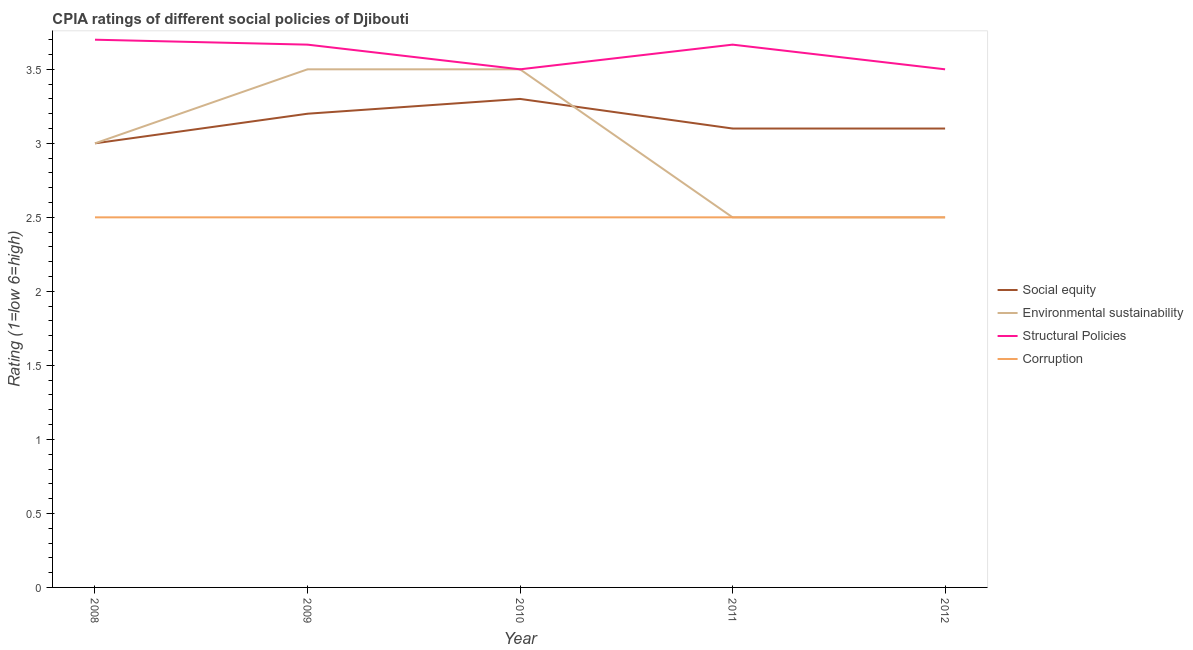Is the number of lines equal to the number of legend labels?
Provide a short and direct response. Yes. Across all years, what is the maximum cpia rating of corruption?
Provide a succinct answer. 2.5. Across all years, what is the minimum cpia rating of corruption?
Ensure brevity in your answer.  2.5. In which year was the cpia rating of corruption minimum?
Your response must be concise. 2008. What is the total cpia rating of environmental sustainability in the graph?
Your answer should be very brief. 15. What is the difference between the cpia rating of environmental sustainability in 2008 and that in 2009?
Ensure brevity in your answer.  -0.5. What is the difference between the cpia rating of social equity in 2010 and the cpia rating of corruption in 2008?
Offer a terse response. 0.8. In the year 2009, what is the difference between the cpia rating of structural policies and cpia rating of corruption?
Ensure brevity in your answer.  1.17. In how many years, is the cpia rating of corruption greater than 1?
Make the answer very short. 5. What is the ratio of the cpia rating of social equity in 2008 to that in 2012?
Your answer should be very brief. 0.97. Is the difference between the cpia rating of structural policies in 2010 and 2011 greater than the difference between the cpia rating of social equity in 2010 and 2011?
Provide a short and direct response. No. What is the difference between the highest and the second highest cpia rating of environmental sustainability?
Provide a short and direct response. 0. What is the difference between the highest and the lowest cpia rating of structural policies?
Offer a terse response. 0.2. Is it the case that in every year, the sum of the cpia rating of social equity and cpia rating of structural policies is greater than the sum of cpia rating of corruption and cpia rating of environmental sustainability?
Your response must be concise. Yes. Is it the case that in every year, the sum of the cpia rating of social equity and cpia rating of environmental sustainability is greater than the cpia rating of structural policies?
Your answer should be very brief. Yes. Does the cpia rating of social equity monotonically increase over the years?
Provide a short and direct response. No. Is the cpia rating of social equity strictly greater than the cpia rating of structural policies over the years?
Give a very brief answer. No. Is the cpia rating of social equity strictly less than the cpia rating of corruption over the years?
Provide a succinct answer. No. How many years are there in the graph?
Your answer should be very brief. 5. What is the difference between two consecutive major ticks on the Y-axis?
Keep it short and to the point. 0.5. Are the values on the major ticks of Y-axis written in scientific E-notation?
Offer a terse response. No. Does the graph contain any zero values?
Your answer should be compact. No. What is the title of the graph?
Your answer should be compact. CPIA ratings of different social policies of Djibouti. What is the label or title of the X-axis?
Your answer should be very brief. Year. What is the Rating (1=low 6=high) in Environmental sustainability in 2008?
Make the answer very short. 3. What is the Rating (1=low 6=high) of Structural Policies in 2009?
Offer a very short reply. 3.67. What is the Rating (1=low 6=high) of Social equity in 2010?
Offer a very short reply. 3.3. What is the Rating (1=low 6=high) of Environmental sustainability in 2010?
Offer a terse response. 3.5. What is the Rating (1=low 6=high) in Corruption in 2010?
Your response must be concise. 2.5. What is the Rating (1=low 6=high) of Environmental sustainability in 2011?
Your response must be concise. 2.5. What is the Rating (1=low 6=high) of Structural Policies in 2011?
Keep it short and to the point. 3.67. What is the Rating (1=low 6=high) in Corruption in 2011?
Make the answer very short. 2.5. What is the Rating (1=low 6=high) in Corruption in 2012?
Offer a very short reply. 2.5. Across all years, what is the minimum Rating (1=low 6=high) in Social equity?
Ensure brevity in your answer.  3. Across all years, what is the minimum Rating (1=low 6=high) in Environmental sustainability?
Your answer should be compact. 2.5. What is the total Rating (1=low 6=high) in Environmental sustainability in the graph?
Give a very brief answer. 15. What is the total Rating (1=low 6=high) of Structural Policies in the graph?
Keep it short and to the point. 18.03. What is the total Rating (1=low 6=high) in Corruption in the graph?
Your answer should be very brief. 12.5. What is the difference between the Rating (1=low 6=high) of Environmental sustainability in 2008 and that in 2009?
Ensure brevity in your answer.  -0.5. What is the difference between the Rating (1=low 6=high) of Structural Policies in 2008 and that in 2009?
Your response must be concise. 0.03. What is the difference between the Rating (1=low 6=high) of Corruption in 2008 and that in 2009?
Offer a terse response. 0. What is the difference between the Rating (1=low 6=high) in Environmental sustainability in 2008 and that in 2010?
Give a very brief answer. -0.5. What is the difference between the Rating (1=low 6=high) in Social equity in 2008 and that in 2011?
Offer a terse response. -0.1. What is the difference between the Rating (1=low 6=high) in Corruption in 2008 and that in 2011?
Your answer should be compact. 0. What is the difference between the Rating (1=low 6=high) in Environmental sustainability in 2008 and that in 2012?
Your answer should be very brief. 0.5. What is the difference between the Rating (1=low 6=high) of Environmental sustainability in 2009 and that in 2010?
Offer a very short reply. 0. What is the difference between the Rating (1=low 6=high) of Structural Policies in 2009 and that in 2010?
Offer a terse response. 0.17. What is the difference between the Rating (1=low 6=high) in Corruption in 2009 and that in 2010?
Your answer should be compact. 0. What is the difference between the Rating (1=low 6=high) of Social equity in 2009 and that in 2011?
Your answer should be compact. 0.1. What is the difference between the Rating (1=low 6=high) in Environmental sustainability in 2009 and that in 2011?
Provide a succinct answer. 1. What is the difference between the Rating (1=low 6=high) of Structural Policies in 2009 and that in 2011?
Make the answer very short. 0. What is the difference between the Rating (1=low 6=high) of Corruption in 2009 and that in 2011?
Ensure brevity in your answer.  0. What is the difference between the Rating (1=low 6=high) of Social equity in 2009 and that in 2012?
Offer a terse response. 0.1. What is the difference between the Rating (1=low 6=high) of Environmental sustainability in 2009 and that in 2012?
Ensure brevity in your answer.  1. What is the difference between the Rating (1=low 6=high) in Structural Policies in 2009 and that in 2012?
Keep it short and to the point. 0.17. What is the difference between the Rating (1=low 6=high) of Corruption in 2009 and that in 2012?
Ensure brevity in your answer.  0. What is the difference between the Rating (1=low 6=high) of Structural Policies in 2010 and that in 2011?
Provide a short and direct response. -0.17. What is the difference between the Rating (1=low 6=high) in Corruption in 2010 and that in 2011?
Offer a very short reply. 0. What is the difference between the Rating (1=low 6=high) of Social equity in 2010 and that in 2012?
Your answer should be very brief. 0.2. What is the difference between the Rating (1=low 6=high) of Social equity in 2011 and that in 2012?
Offer a terse response. 0. What is the difference between the Rating (1=low 6=high) of Environmental sustainability in 2011 and that in 2012?
Your answer should be compact. 0. What is the difference between the Rating (1=low 6=high) of Corruption in 2011 and that in 2012?
Make the answer very short. 0. What is the difference between the Rating (1=low 6=high) in Social equity in 2008 and the Rating (1=low 6=high) in Environmental sustainability in 2009?
Your answer should be very brief. -0.5. What is the difference between the Rating (1=low 6=high) in Social equity in 2008 and the Rating (1=low 6=high) in Structural Policies in 2009?
Provide a succinct answer. -0.67. What is the difference between the Rating (1=low 6=high) of Social equity in 2008 and the Rating (1=low 6=high) of Corruption in 2009?
Ensure brevity in your answer.  0.5. What is the difference between the Rating (1=low 6=high) in Environmental sustainability in 2008 and the Rating (1=low 6=high) in Structural Policies in 2009?
Your response must be concise. -0.67. What is the difference between the Rating (1=low 6=high) in Environmental sustainability in 2008 and the Rating (1=low 6=high) in Corruption in 2009?
Ensure brevity in your answer.  0.5. What is the difference between the Rating (1=low 6=high) of Structural Policies in 2008 and the Rating (1=low 6=high) of Corruption in 2009?
Your response must be concise. 1.2. What is the difference between the Rating (1=low 6=high) in Social equity in 2008 and the Rating (1=low 6=high) in Environmental sustainability in 2010?
Your answer should be compact. -0.5. What is the difference between the Rating (1=low 6=high) of Social equity in 2008 and the Rating (1=low 6=high) of Corruption in 2010?
Provide a succinct answer. 0.5. What is the difference between the Rating (1=low 6=high) in Environmental sustainability in 2008 and the Rating (1=low 6=high) in Corruption in 2010?
Make the answer very short. 0.5. What is the difference between the Rating (1=low 6=high) in Structural Policies in 2008 and the Rating (1=low 6=high) in Corruption in 2010?
Your answer should be very brief. 1.2. What is the difference between the Rating (1=low 6=high) in Social equity in 2008 and the Rating (1=low 6=high) in Environmental sustainability in 2011?
Give a very brief answer. 0.5. What is the difference between the Rating (1=low 6=high) in Social equity in 2008 and the Rating (1=low 6=high) in Structural Policies in 2011?
Provide a succinct answer. -0.67. What is the difference between the Rating (1=low 6=high) in Environmental sustainability in 2008 and the Rating (1=low 6=high) in Corruption in 2011?
Offer a terse response. 0.5. What is the difference between the Rating (1=low 6=high) of Structural Policies in 2008 and the Rating (1=low 6=high) of Corruption in 2011?
Offer a terse response. 1.2. What is the difference between the Rating (1=low 6=high) in Structural Policies in 2008 and the Rating (1=low 6=high) in Corruption in 2012?
Your answer should be compact. 1.2. What is the difference between the Rating (1=low 6=high) in Social equity in 2009 and the Rating (1=low 6=high) in Environmental sustainability in 2010?
Make the answer very short. -0.3. What is the difference between the Rating (1=low 6=high) of Social equity in 2009 and the Rating (1=low 6=high) of Structural Policies in 2010?
Keep it short and to the point. -0.3. What is the difference between the Rating (1=low 6=high) in Social equity in 2009 and the Rating (1=low 6=high) in Corruption in 2010?
Offer a very short reply. 0.7. What is the difference between the Rating (1=low 6=high) in Environmental sustainability in 2009 and the Rating (1=low 6=high) in Corruption in 2010?
Offer a very short reply. 1. What is the difference between the Rating (1=low 6=high) in Structural Policies in 2009 and the Rating (1=low 6=high) in Corruption in 2010?
Your answer should be very brief. 1.17. What is the difference between the Rating (1=low 6=high) of Social equity in 2009 and the Rating (1=low 6=high) of Structural Policies in 2011?
Ensure brevity in your answer.  -0.47. What is the difference between the Rating (1=low 6=high) in Social equity in 2009 and the Rating (1=low 6=high) in Environmental sustainability in 2012?
Your answer should be very brief. 0.7. What is the difference between the Rating (1=low 6=high) of Social equity in 2009 and the Rating (1=low 6=high) of Corruption in 2012?
Offer a very short reply. 0.7. What is the difference between the Rating (1=low 6=high) of Environmental sustainability in 2009 and the Rating (1=low 6=high) of Structural Policies in 2012?
Make the answer very short. 0. What is the difference between the Rating (1=low 6=high) in Environmental sustainability in 2009 and the Rating (1=low 6=high) in Corruption in 2012?
Provide a short and direct response. 1. What is the difference between the Rating (1=low 6=high) in Social equity in 2010 and the Rating (1=low 6=high) in Environmental sustainability in 2011?
Make the answer very short. 0.8. What is the difference between the Rating (1=low 6=high) in Social equity in 2010 and the Rating (1=low 6=high) in Structural Policies in 2011?
Provide a succinct answer. -0.37. What is the difference between the Rating (1=low 6=high) in Social equity in 2010 and the Rating (1=low 6=high) in Corruption in 2011?
Your answer should be very brief. 0.8. What is the difference between the Rating (1=low 6=high) of Environmental sustainability in 2010 and the Rating (1=low 6=high) of Corruption in 2011?
Provide a succinct answer. 1. What is the difference between the Rating (1=low 6=high) of Social equity in 2010 and the Rating (1=low 6=high) of Structural Policies in 2012?
Make the answer very short. -0.2. What is the difference between the Rating (1=low 6=high) of Environmental sustainability in 2011 and the Rating (1=low 6=high) of Corruption in 2012?
Provide a short and direct response. 0. What is the average Rating (1=low 6=high) in Social equity per year?
Your response must be concise. 3.14. What is the average Rating (1=low 6=high) of Structural Policies per year?
Your response must be concise. 3.61. In the year 2008, what is the difference between the Rating (1=low 6=high) in Social equity and Rating (1=low 6=high) in Structural Policies?
Keep it short and to the point. -0.7. In the year 2008, what is the difference between the Rating (1=low 6=high) of Social equity and Rating (1=low 6=high) of Corruption?
Provide a succinct answer. 0.5. In the year 2008, what is the difference between the Rating (1=low 6=high) in Environmental sustainability and Rating (1=low 6=high) in Corruption?
Keep it short and to the point. 0.5. In the year 2008, what is the difference between the Rating (1=low 6=high) in Structural Policies and Rating (1=low 6=high) in Corruption?
Your answer should be very brief. 1.2. In the year 2009, what is the difference between the Rating (1=low 6=high) of Social equity and Rating (1=low 6=high) of Structural Policies?
Provide a succinct answer. -0.47. In the year 2009, what is the difference between the Rating (1=low 6=high) in Environmental sustainability and Rating (1=low 6=high) in Structural Policies?
Your answer should be very brief. -0.17. In the year 2009, what is the difference between the Rating (1=low 6=high) in Environmental sustainability and Rating (1=low 6=high) in Corruption?
Your answer should be compact. 1. In the year 2009, what is the difference between the Rating (1=low 6=high) of Structural Policies and Rating (1=low 6=high) of Corruption?
Offer a terse response. 1.17. In the year 2010, what is the difference between the Rating (1=low 6=high) of Environmental sustainability and Rating (1=low 6=high) of Structural Policies?
Offer a very short reply. 0. In the year 2010, what is the difference between the Rating (1=low 6=high) of Environmental sustainability and Rating (1=low 6=high) of Corruption?
Offer a terse response. 1. In the year 2010, what is the difference between the Rating (1=low 6=high) in Structural Policies and Rating (1=low 6=high) in Corruption?
Your response must be concise. 1. In the year 2011, what is the difference between the Rating (1=low 6=high) of Social equity and Rating (1=low 6=high) of Environmental sustainability?
Give a very brief answer. 0.6. In the year 2011, what is the difference between the Rating (1=low 6=high) of Social equity and Rating (1=low 6=high) of Structural Policies?
Keep it short and to the point. -0.57. In the year 2011, what is the difference between the Rating (1=low 6=high) of Environmental sustainability and Rating (1=low 6=high) of Structural Policies?
Offer a very short reply. -1.17. In the year 2011, what is the difference between the Rating (1=low 6=high) in Environmental sustainability and Rating (1=low 6=high) in Corruption?
Give a very brief answer. 0. In the year 2011, what is the difference between the Rating (1=low 6=high) in Structural Policies and Rating (1=low 6=high) in Corruption?
Ensure brevity in your answer.  1.17. In the year 2012, what is the difference between the Rating (1=low 6=high) of Environmental sustainability and Rating (1=low 6=high) of Structural Policies?
Keep it short and to the point. -1. In the year 2012, what is the difference between the Rating (1=low 6=high) in Structural Policies and Rating (1=low 6=high) in Corruption?
Offer a very short reply. 1. What is the ratio of the Rating (1=low 6=high) of Structural Policies in 2008 to that in 2009?
Offer a terse response. 1.01. What is the ratio of the Rating (1=low 6=high) of Corruption in 2008 to that in 2009?
Make the answer very short. 1. What is the ratio of the Rating (1=low 6=high) in Social equity in 2008 to that in 2010?
Give a very brief answer. 0.91. What is the ratio of the Rating (1=low 6=high) of Structural Policies in 2008 to that in 2010?
Offer a terse response. 1.06. What is the ratio of the Rating (1=low 6=high) of Corruption in 2008 to that in 2010?
Give a very brief answer. 1. What is the ratio of the Rating (1=low 6=high) in Environmental sustainability in 2008 to that in 2011?
Your answer should be very brief. 1.2. What is the ratio of the Rating (1=low 6=high) of Structural Policies in 2008 to that in 2011?
Your response must be concise. 1.01. What is the ratio of the Rating (1=low 6=high) in Corruption in 2008 to that in 2011?
Ensure brevity in your answer.  1. What is the ratio of the Rating (1=low 6=high) in Environmental sustainability in 2008 to that in 2012?
Give a very brief answer. 1.2. What is the ratio of the Rating (1=low 6=high) in Structural Policies in 2008 to that in 2012?
Keep it short and to the point. 1.06. What is the ratio of the Rating (1=low 6=high) in Corruption in 2008 to that in 2012?
Provide a short and direct response. 1. What is the ratio of the Rating (1=low 6=high) of Social equity in 2009 to that in 2010?
Offer a terse response. 0.97. What is the ratio of the Rating (1=low 6=high) in Environmental sustainability in 2009 to that in 2010?
Make the answer very short. 1. What is the ratio of the Rating (1=low 6=high) in Structural Policies in 2009 to that in 2010?
Offer a very short reply. 1.05. What is the ratio of the Rating (1=low 6=high) of Corruption in 2009 to that in 2010?
Your response must be concise. 1. What is the ratio of the Rating (1=low 6=high) in Social equity in 2009 to that in 2011?
Provide a short and direct response. 1.03. What is the ratio of the Rating (1=low 6=high) of Social equity in 2009 to that in 2012?
Ensure brevity in your answer.  1.03. What is the ratio of the Rating (1=low 6=high) in Environmental sustainability in 2009 to that in 2012?
Your answer should be compact. 1.4. What is the ratio of the Rating (1=low 6=high) in Structural Policies in 2009 to that in 2012?
Your answer should be compact. 1.05. What is the ratio of the Rating (1=low 6=high) in Corruption in 2009 to that in 2012?
Make the answer very short. 1. What is the ratio of the Rating (1=low 6=high) of Social equity in 2010 to that in 2011?
Your answer should be compact. 1.06. What is the ratio of the Rating (1=low 6=high) of Environmental sustainability in 2010 to that in 2011?
Your answer should be very brief. 1.4. What is the ratio of the Rating (1=low 6=high) in Structural Policies in 2010 to that in 2011?
Make the answer very short. 0.95. What is the ratio of the Rating (1=low 6=high) of Social equity in 2010 to that in 2012?
Offer a terse response. 1.06. What is the ratio of the Rating (1=low 6=high) of Environmental sustainability in 2010 to that in 2012?
Make the answer very short. 1.4. What is the ratio of the Rating (1=low 6=high) in Structural Policies in 2010 to that in 2012?
Provide a short and direct response. 1. What is the ratio of the Rating (1=low 6=high) in Corruption in 2010 to that in 2012?
Offer a terse response. 1. What is the ratio of the Rating (1=low 6=high) of Social equity in 2011 to that in 2012?
Your answer should be compact. 1. What is the ratio of the Rating (1=low 6=high) in Environmental sustainability in 2011 to that in 2012?
Offer a very short reply. 1. What is the ratio of the Rating (1=low 6=high) in Structural Policies in 2011 to that in 2012?
Your answer should be very brief. 1.05. What is the difference between the highest and the lowest Rating (1=low 6=high) of Environmental sustainability?
Keep it short and to the point. 1. What is the difference between the highest and the lowest Rating (1=low 6=high) in Structural Policies?
Provide a succinct answer. 0.2. 